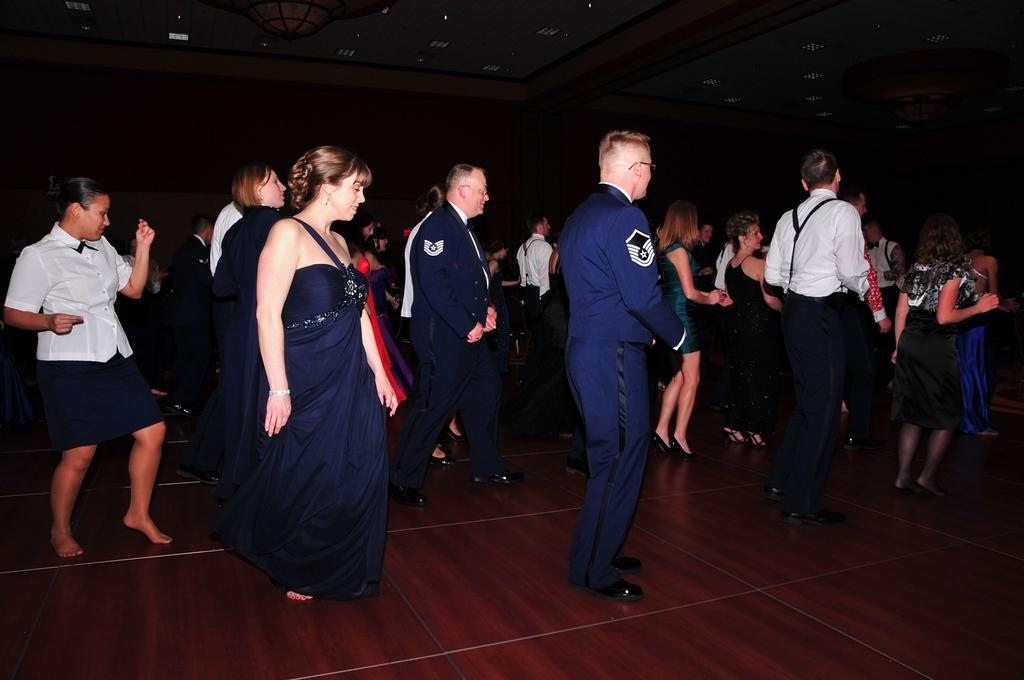What is happening in the image involving the people? The people appear to be dancing in the image. Where is the dancing taking place? The dancing is taking place in a room. What can be seen on the ceiling of the room? There are lights attached to the ceiling in the room. What type of trade is being conducted in the image? There is no trade being conducted in the image; it features people dancing in a room. Can you describe the jelly that is present in the image? There is no jelly present in the image. 